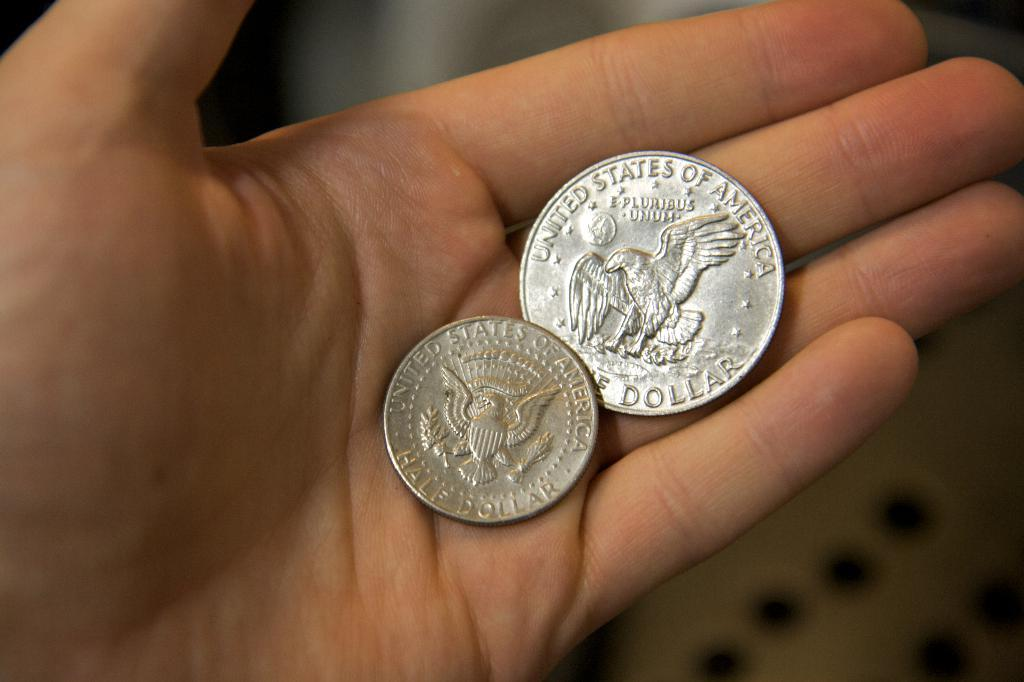<image>
Relay a brief, clear account of the picture shown. A man a half dollar coin and single dollar coin. 